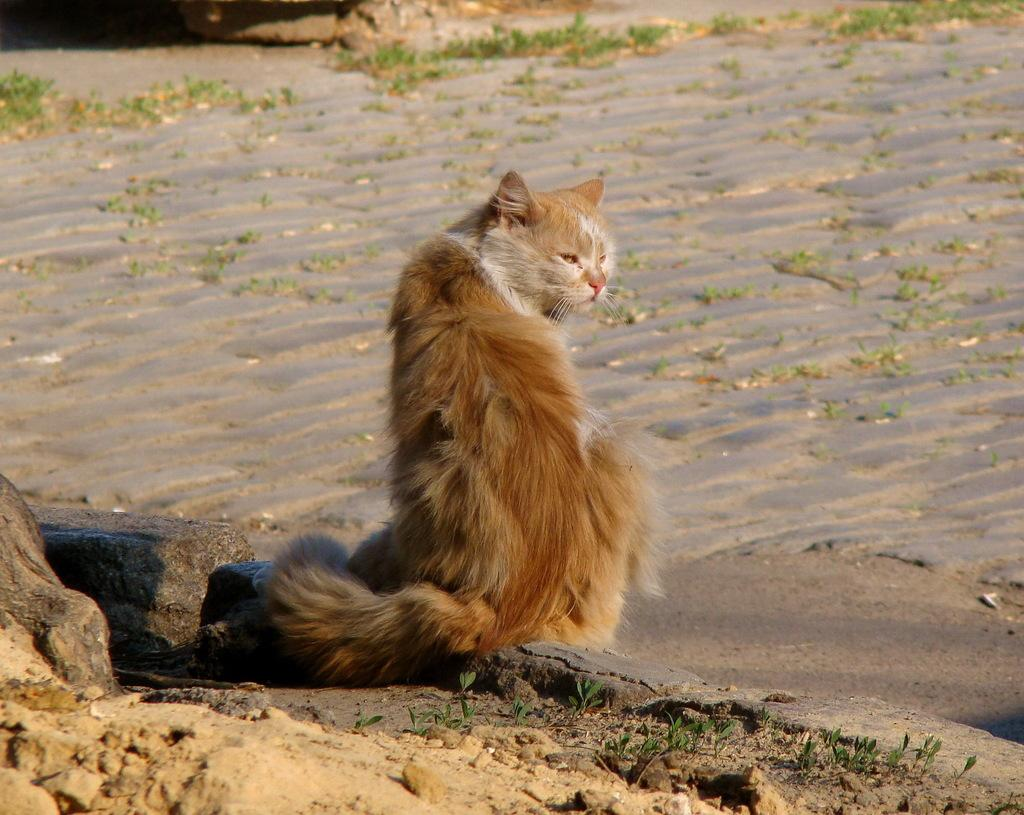What animal is in the middle of the image? There is a cat in the middle of the image. What type of terrain is at the bottom of the image? There are stones at the bottom of the image. What type of environment is visible in the image? There is grassland in the image. What can be seen in the background of the image? There are plants and land visible in the background of the image. What type of bread can be seen in the image? There is no bread present in the image. Is there a trail visible in the image? There is no trail visible in the image. 